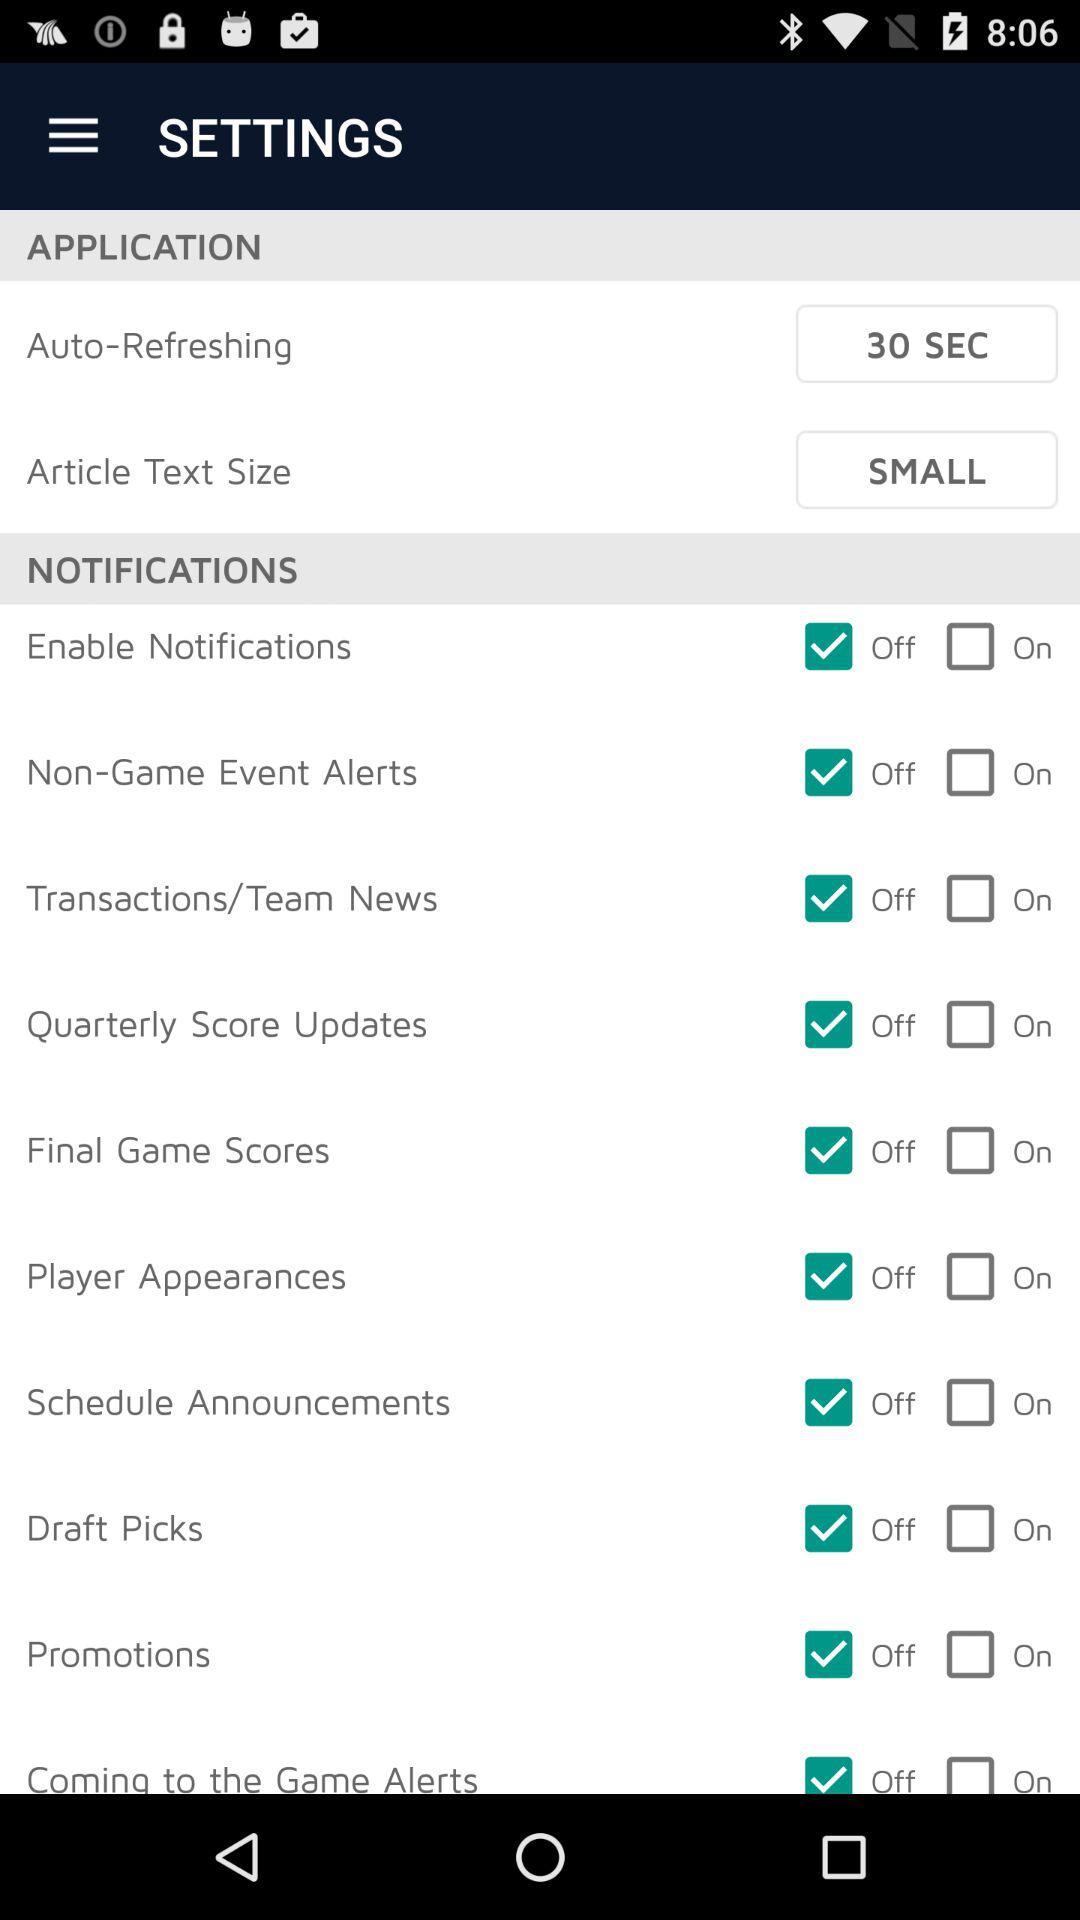What's the "Auto-Refreshing" time? The time is 30 seconds. 